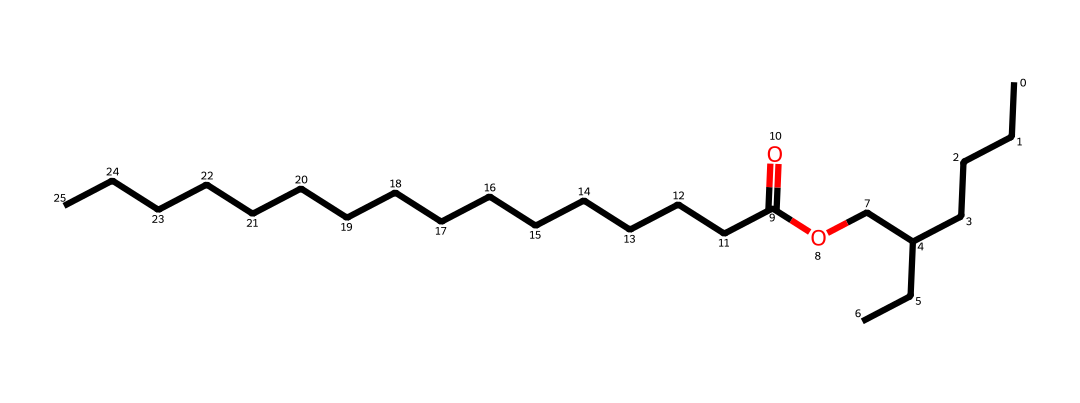What is the main functional group present in this compound? The compound contains an ether functional group represented by the -O- linkage. This is identified in the structure where oxygen is bonded between two carbon chains.
Answer: ether How many carbon atoms are present in the molecule? By counting the number of carbon (C) atoms in the SMILES representation, there are 21 carbon atoms indicated as part of the structure.
Answer: 21 What type of bond primarily connects the carbon atoms in this molecule? The majority of the carbon atoms are connected by single bonds, as indicated by the lack of double bonds between the carbon atoms in the chain.
Answer: single bonds What is the longest continuous carbon chain in the molecule? Analyzing the structure, the longest carbon chain consists of a 15-carbon segment on one side and a 6-carbon segment on the other, leading to the longest continuous chain being 15 carbons long.
Answer: 15 Is this compound likely to be hydrophobic or hydrophilic? Given the long hydrophobic hydrocarbon chains present in the ether compound, it will predominantly exhibit hydrophobic characteristics and repel water.
Answer: hydrophobic How many oxygen atoms are present in the molecule? From the SMILES representation, there is one oxygen atom indicated, which is part of the ether functional group.
Answer: 1 